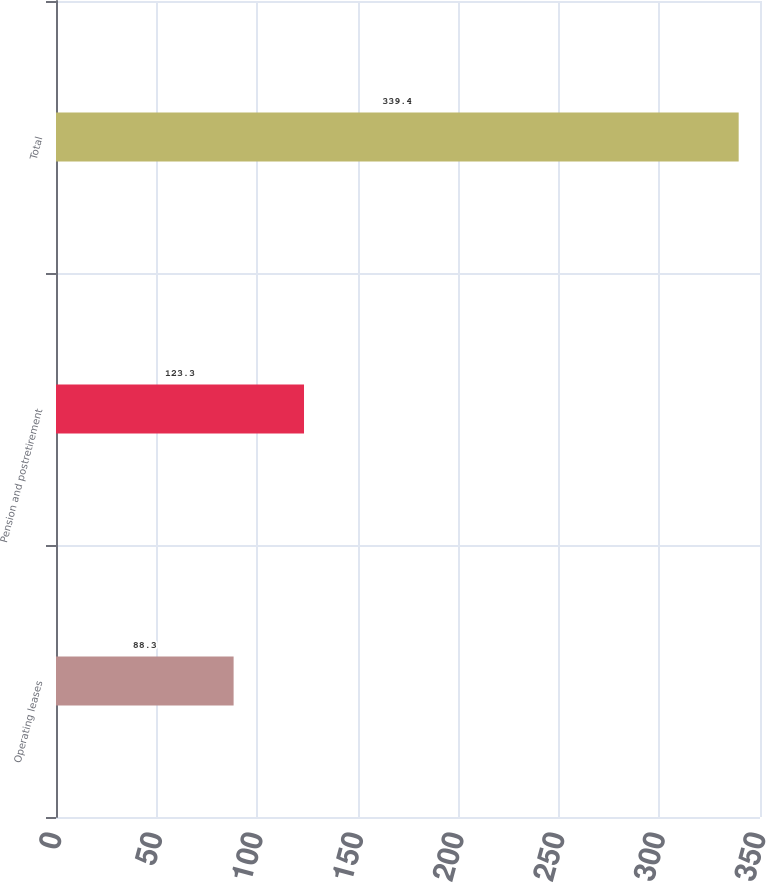Convert chart. <chart><loc_0><loc_0><loc_500><loc_500><bar_chart><fcel>Operating leases<fcel>Pension and postretirement<fcel>Total<nl><fcel>88.3<fcel>123.3<fcel>339.4<nl></chart> 